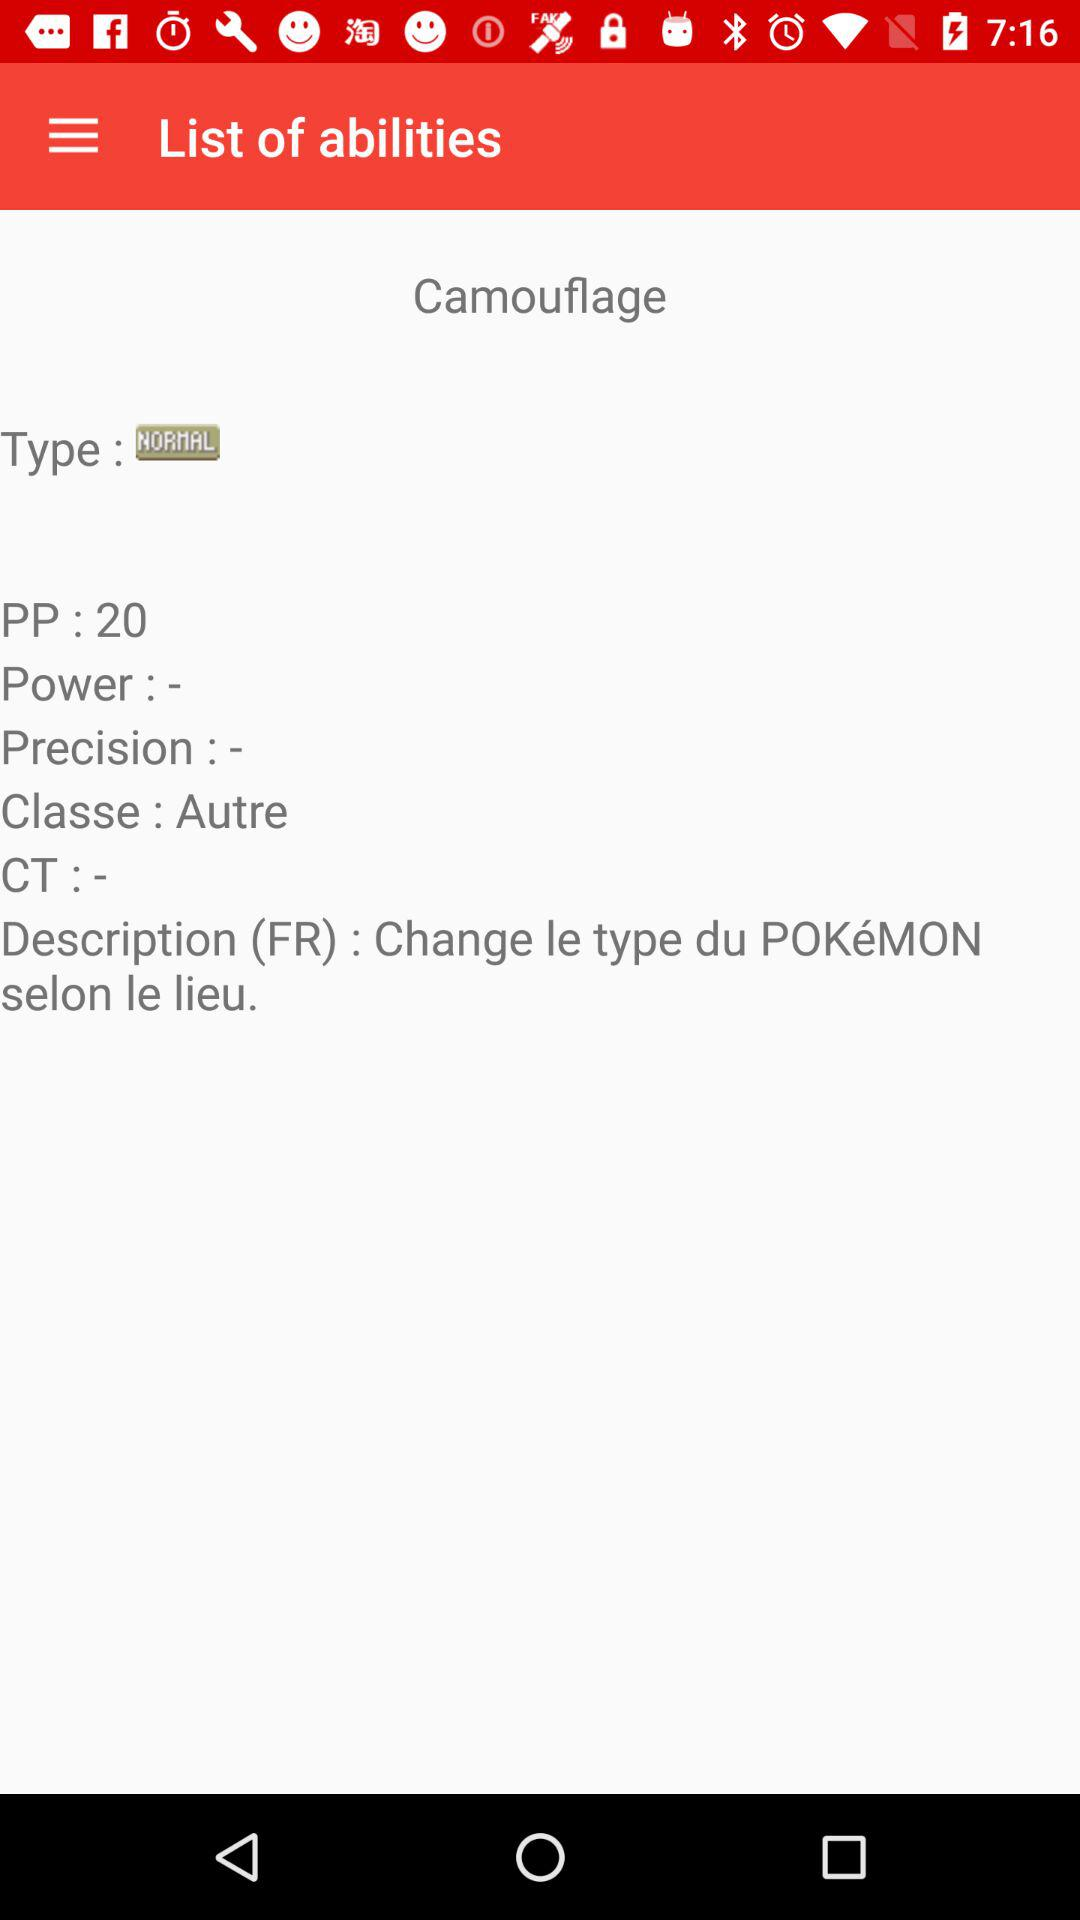What is the type? The type is normal. 